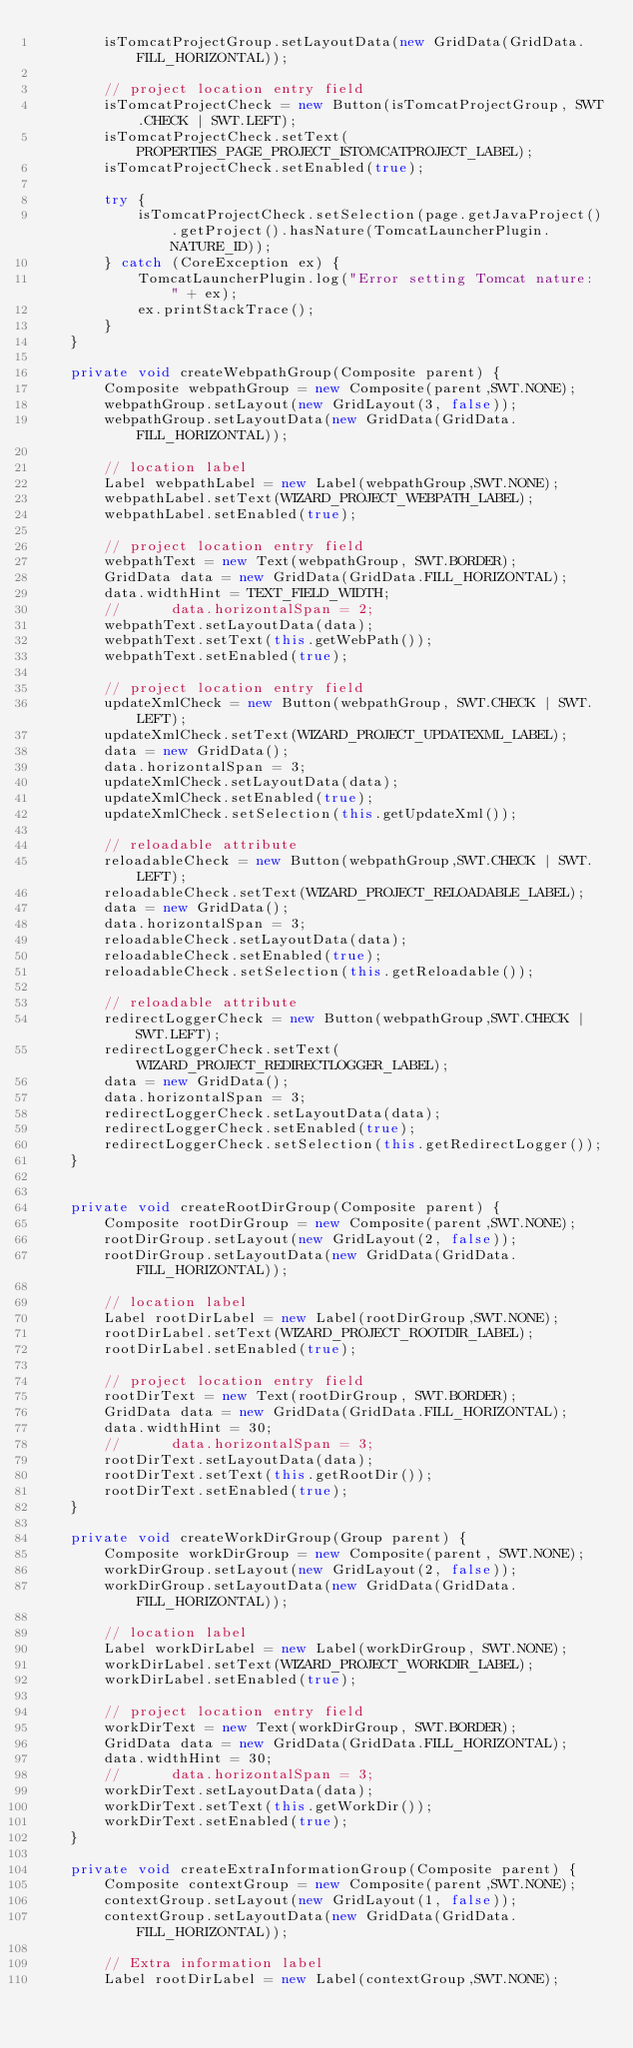Convert code to text. <code><loc_0><loc_0><loc_500><loc_500><_Java_>        isTomcatProjectGroup.setLayoutData(new GridData(GridData.FILL_HORIZONTAL));

        // project location entry field
        isTomcatProjectCheck = new Button(isTomcatProjectGroup, SWT.CHECK | SWT.LEFT);
        isTomcatProjectCheck.setText(PROPERTIES_PAGE_PROJECT_ISTOMCATPROJECT_LABEL);
        isTomcatProjectCheck.setEnabled(true);

        try {
            isTomcatProjectCheck.setSelection(page.getJavaProject().getProject().hasNature(TomcatLauncherPlugin.NATURE_ID));
        } catch (CoreException ex) {
            TomcatLauncherPlugin.log("Error setting Tomcat nature: " + ex);
            ex.printStackTrace();
        }
    }

    private void createWebpathGroup(Composite parent) {
        Composite webpathGroup = new Composite(parent,SWT.NONE);
        webpathGroup.setLayout(new GridLayout(3, false));
        webpathGroup.setLayoutData(new GridData(GridData.FILL_HORIZONTAL));

        // location label
        Label webpathLabel = new Label(webpathGroup,SWT.NONE);
        webpathLabel.setText(WIZARD_PROJECT_WEBPATH_LABEL);
        webpathLabel.setEnabled(true);

        // project location entry field
        webpathText = new Text(webpathGroup, SWT.BORDER);
        GridData data = new GridData(GridData.FILL_HORIZONTAL);
        data.widthHint = TEXT_FIELD_WIDTH;
        //		data.horizontalSpan = 2;
        webpathText.setLayoutData(data);
        webpathText.setText(this.getWebPath());
        webpathText.setEnabled(true);

        // project location entry field
        updateXmlCheck = new Button(webpathGroup, SWT.CHECK | SWT.LEFT);
        updateXmlCheck.setText(WIZARD_PROJECT_UPDATEXML_LABEL);
        data = new GridData();
        data.horizontalSpan = 3;
        updateXmlCheck.setLayoutData(data);
        updateXmlCheck.setEnabled(true);
        updateXmlCheck.setSelection(this.getUpdateXml());

        // reloadable attribute
        reloadableCheck = new Button(webpathGroup,SWT.CHECK | SWT.LEFT);
        reloadableCheck.setText(WIZARD_PROJECT_RELOADABLE_LABEL);
        data = new GridData();
        data.horizontalSpan = 3;
        reloadableCheck.setLayoutData(data);
        reloadableCheck.setEnabled(true);
        reloadableCheck.setSelection(this.getReloadable());

        // reloadable attribute
        redirectLoggerCheck = new Button(webpathGroup,SWT.CHECK | SWT.LEFT);
        redirectLoggerCheck.setText(WIZARD_PROJECT_REDIRECTLOGGER_LABEL);
        data = new GridData();
        data.horizontalSpan = 3;
        redirectLoggerCheck.setLayoutData(data);
        redirectLoggerCheck.setEnabled(true);
        redirectLoggerCheck.setSelection(this.getRedirectLogger());
    }


    private void createRootDirGroup(Composite parent) {
        Composite rootDirGroup = new Composite(parent,SWT.NONE);
        rootDirGroup.setLayout(new GridLayout(2, false));
        rootDirGroup.setLayoutData(new GridData(GridData.FILL_HORIZONTAL));

        // location label
        Label rootDirLabel = new Label(rootDirGroup,SWT.NONE);
        rootDirLabel.setText(WIZARD_PROJECT_ROOTDIR_LABEL);
        rootDirLabel.setEnabled(true);

        // project location entry field
        rootDirText = new Text(rootDirGroup, SWT.BORDER);
        GridData data = new GridData(GridData.FILL_HORIZONTAL);
        data.widthHint = 30;
        //		data.horizontalSpan = 3;
        rootDirText.setLayoutData(data);
        rootDirText.setText(this.getRootDir());
        rootDirText.setEnabled(true);
    }

    private void createWorkDirGroup(Group parent) {
        Composite workDirGroup = new Composite(parent, SWT.NONE);
        workDirGroup.setLayout(new GridLayout(2, false));
        workDirGroup.setLayoutData(new GridData(GridData.FILL_HORIZONTAL));

        // location label
        Label workDirLabel = new Label(workDirGroup, SWT.NONE);
        workDirLabel.setText(WIZARD_PROJECT_WORKDIR_LABEL);
        workDirLabel.setEnabled(true);

        // project location entry field
        workDirText = new Text(workDirGroup, SWT.BORDER);
        GridData data = new GridData(GridData.FILL_HORIZONTAL);
        data.widthHint = 30;
        //      data.horizontalSpan = 3;
        workDirText.setLayoutData(data);
        workDirText.setText(this.getWorkDir());
        workDirText.setEnabled(true);
    }

    private void createExtraInformationGroup(Composite parent) {
        Composite contextGroup = new Composite(parent,SWT.NONE);
        contextGroup.setLayout(new GridLayout(1, false));
        contextGroup.setLayoutData(new GridData(GridData.FILL_HORIZONTAL));

        // Extra information label
        Label rootDirLabel = new Label(contextGroup,SWT.NONE);</code> 